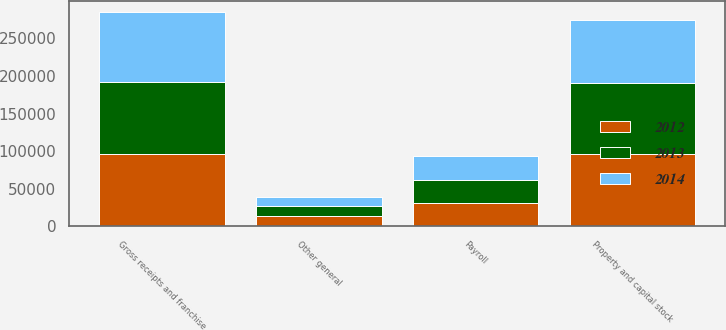Convert chart. <chart><loc_0><loc_0><loc_500><loc_500><stacked_bar_chart><ecel><fcel>Gross receipts and franchise<fcel>Property and capital stock<fcel>Payroll<fcel>Other general<nl><fcel>2012<fcel>96014<fcel>95651<fcel>30698<fcel>14369<nl><fcel>2013<fcel>96044<fcel>94394<fcel>30985<fcel>12775<nl><fcel>2014<fcel>92612<fcel>84448<fcel>32335<fcel>11363<nl></chart> 